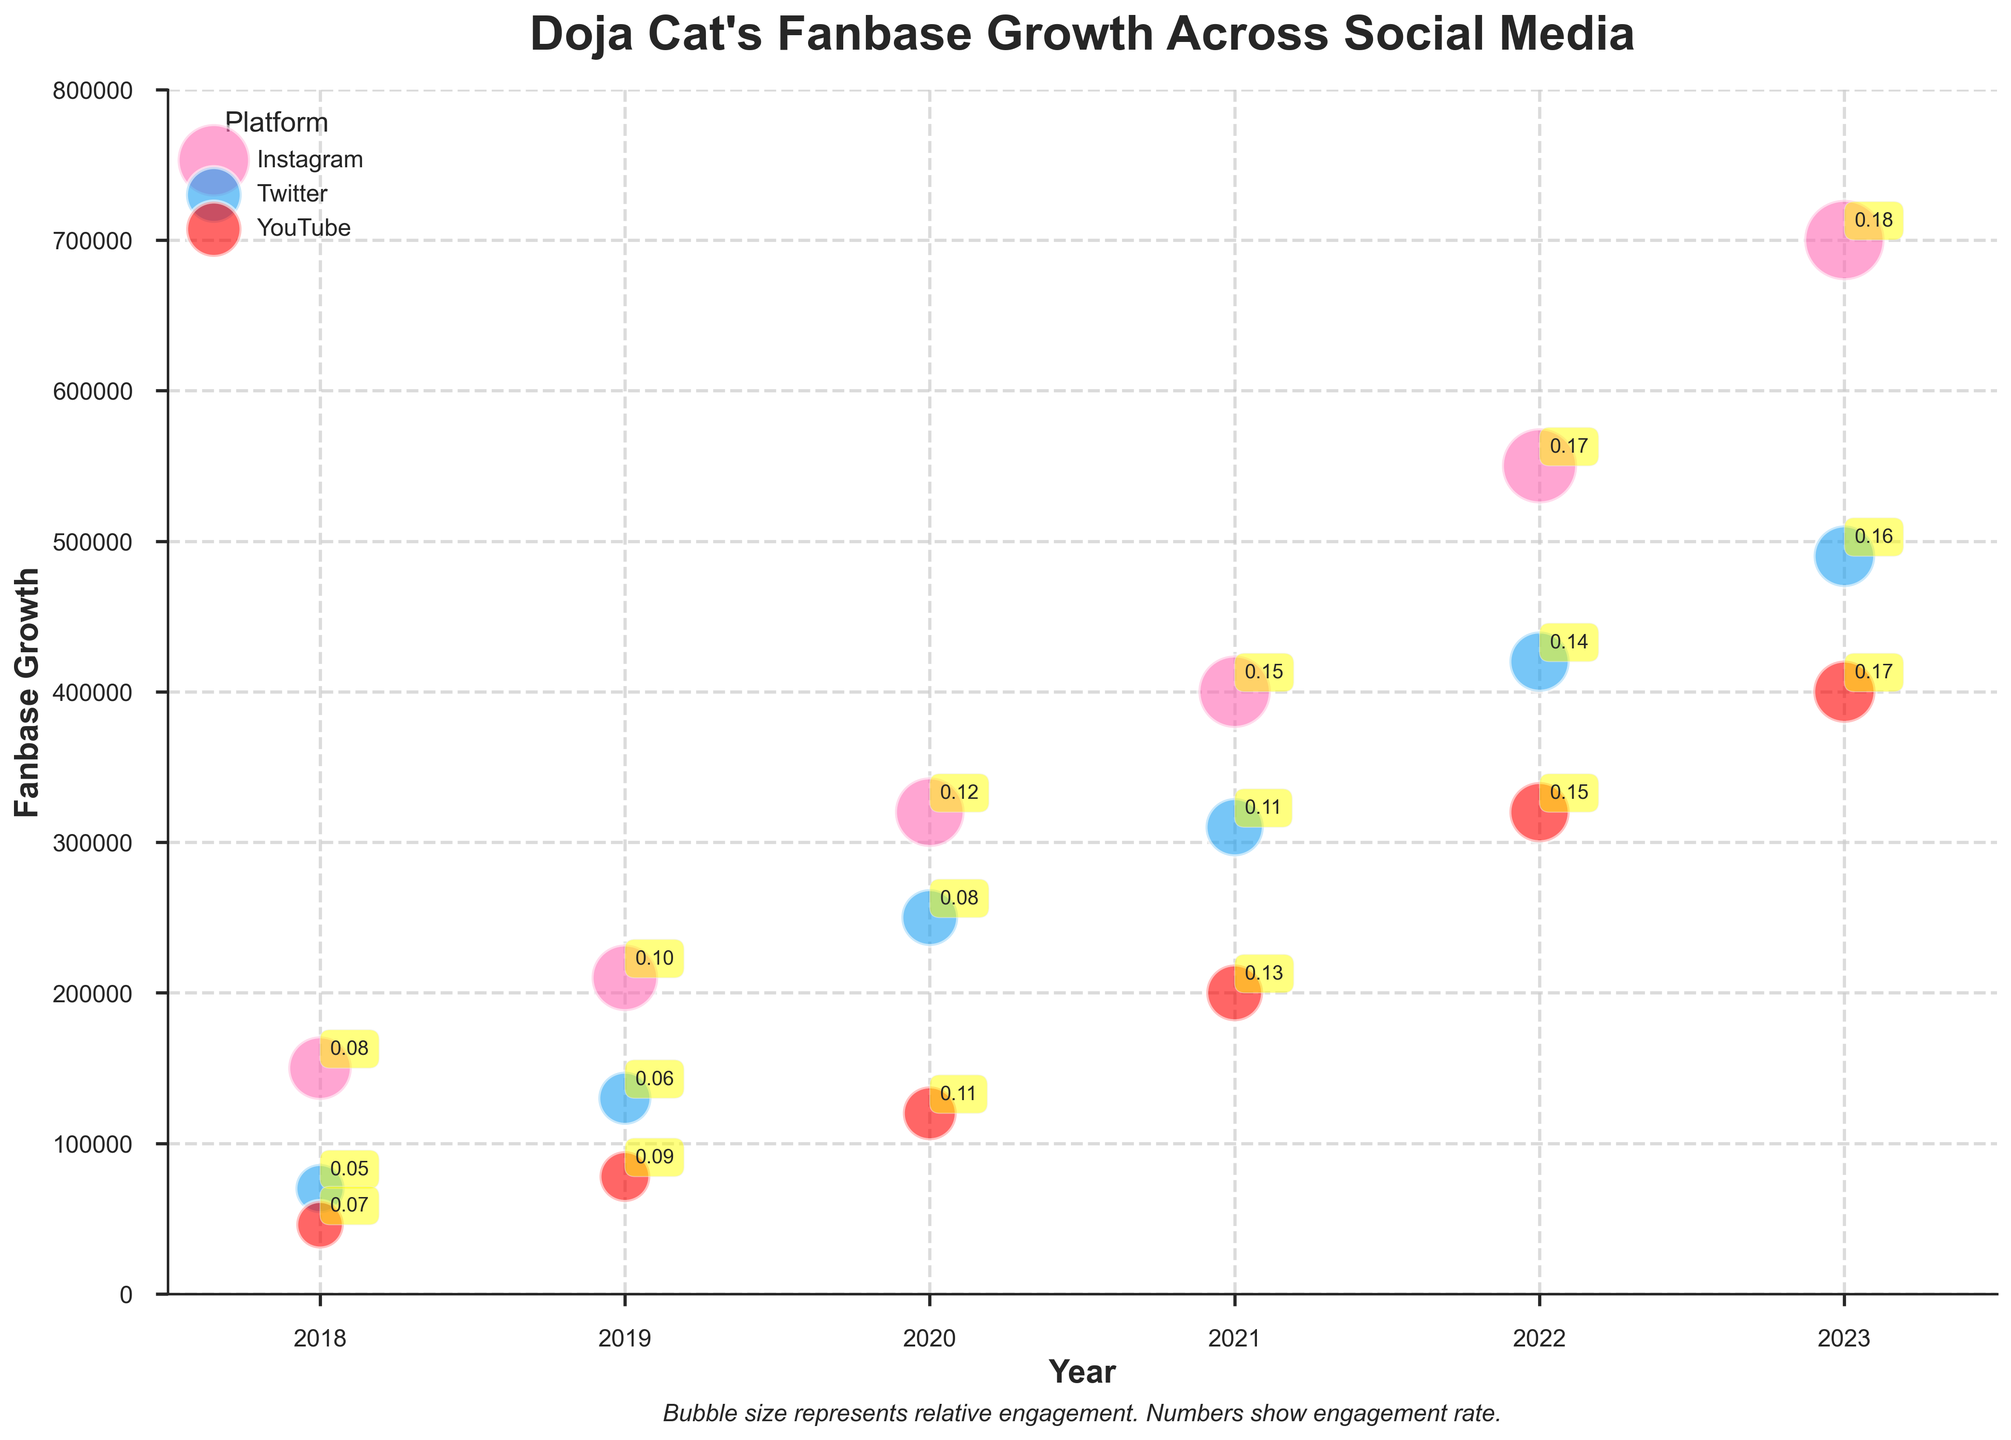What is the title of the chart? The title of the chart is displayed at the top-center of the figure, set in bold and large font. It describes the chart's focus, which is "Doja Cat's Fanbase Growth Across Social Media."
Answer: Doja Cat's Fanbase Growth Across Social Media Which social media platform had the highest fanbase growth in 2023? To determine which platform had the highest fanbase growth in 2023, look at the year 2023 on the x-axis and find the highest bubble on the y-axis. The Instagram bubble is the highest in 2023, indicating the highest fanbase growth.
Answer: Instagram How much did the fanbase grow for YouTube between 2021 and 2023? Subtract the YouTube fanbase growth value from 2021 from the YouTube fanbase growth value from 2023. In 2021, the fanbase growth was 200,000, and in 2023, it was 400,000. The difference is 400,000 - 200,000.
Answer: 200,000 Which platform showed a higher engagement rate in 2020, Instagram or Twitter? The engagement rate for Instagram in 2020 is displayed on the bubble near the year 2020 on the x-axis, marked as 0.12. For Twitter, it is marked as 0.08 in the same year. Compare these two values.
Answer: Instagram What does the bubble size represent in the chart? The bubble size in the chart represents relative engagement on each social media platform for each year. This information is also clarified in the text below the chart.
Answer: Relative engagement Which platform had the most consistent fanbase growth from 2018 to 2023? To determine consistency in fanbase growth, track the fanbase growth values of each platform from 2018 to 2023. Check which platform shows steady and gradual increases without sudden spikes or drops. Instagram shows a consistent increase in fanbase growth each year.
Answer: Instagram Compare the engagement rate for YouTube in 2019 and Instagram in 2022. Which is higher, and by how much? Find the engagement rate for YouTube in 2019 (0.09) and Instagram in 2022 (0.17). Subtract the lower engagement rate from the higher one to find the difference: 0.17 - 0.09.
Answer: Instagram by 0.08 What is the trend of Twitter's fanbase growth from 2018 to 2023? To identify the trend, track the fanbase growth values for Twitter from 2018 (70,000) to 2023 (490,000). The values show a consistent increase each year, indicating a rising trend in Twitter's fanbase growth.
Answer: Rising trend 